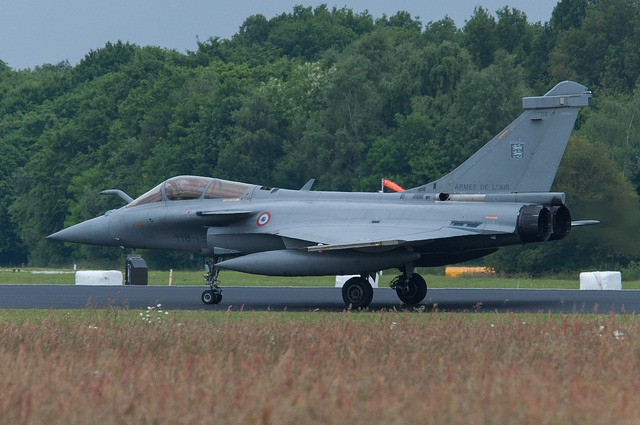Describe the objects in this image and their specific colors. I can see a airplane in darkgray, black, and gray tones in this image. 